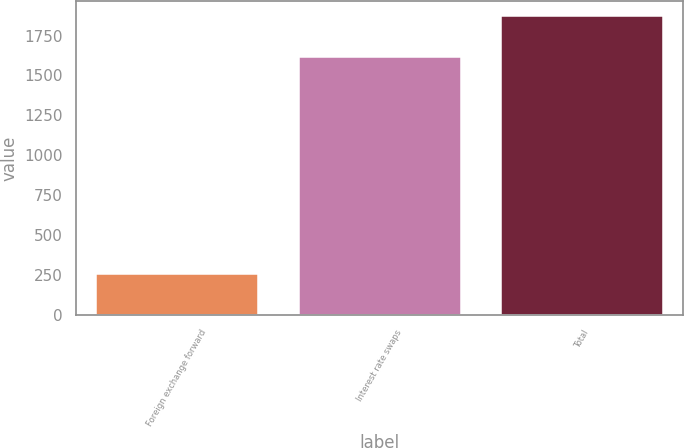Convert chart to OTSL. <chart><loc_0><loc_0><loc_500><loc_500><bar_chart><fcel>Foreign exchange forward<fcel>Interest rate swaps<fcel>Total<nl><fcel>255<fcel>1617<fcel>1873<nl></chart> 